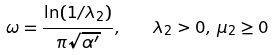<formula> <loc_0><loc_0><loc_500><loc_500>\omega = { \frac { \ln ( 1 / { \lambda _ { 2 } } ) } { \pi \sqrt { \alpha ^ { \prime } } } } , \quad \lambda _ { 2 } > 0 , \, { \mu _ { 2 } } \geq 0</formula> 